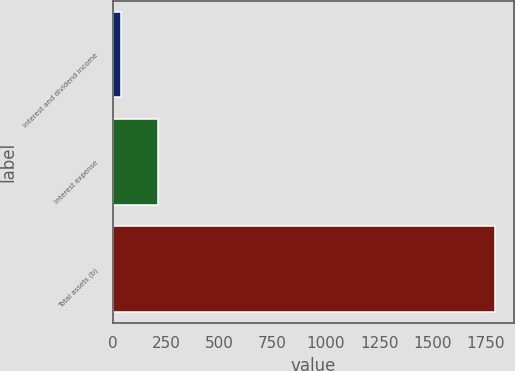Convert chart to OTSL. <chart><loc_0><loc_0><loc_500><loc_500><bar_chart><fcel>Interest and dividend income<fcel>Interest expense<fcel>Total assets (b)<nl><fcel>38<fcel>213.7<fcel>1795<nl></chart> 